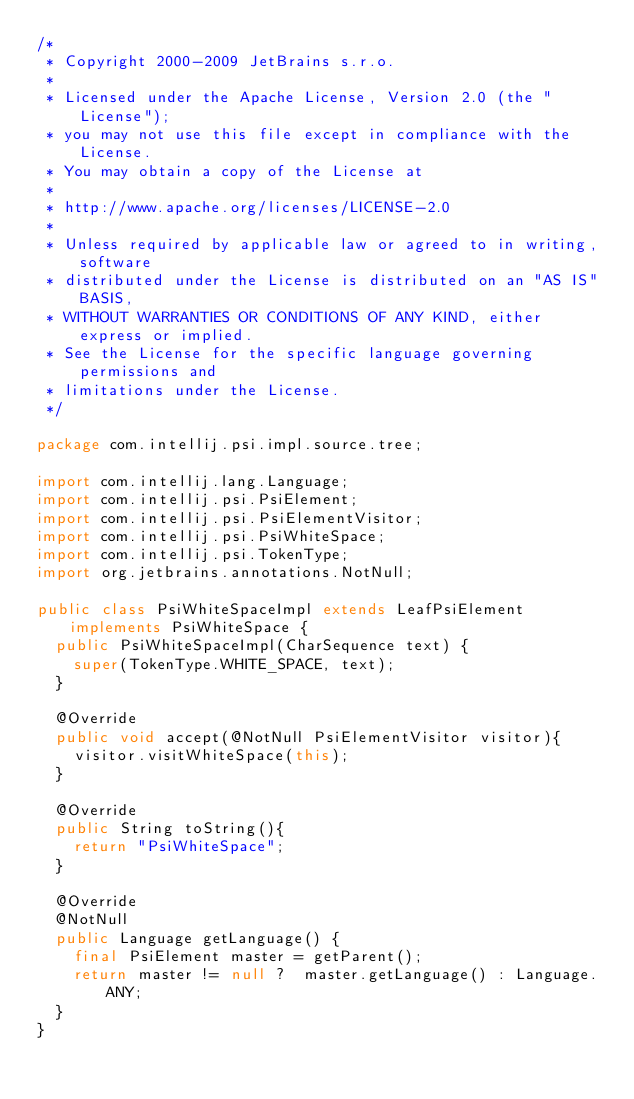<code> <loc_0><loc_0><loc_500><loc_500><_Java_>/*
 * Copyright 2000-2009 JetBrains s.r.o.
 *
 * Licensed under the Apache License, Version 2.0 (the "License");
 * you may not use this file except in compliance with the License.
 * You may obtain a copy of the License at
 *
 * http://www.apache.org/licenses/LICENSE-2.0
 *
 * Unless required by applicable law or agreed to in writing, software
 * distributed under the License is distributed on an "AS IS" BASIS,
 * WITHOUT WARRANTIES OR CONDITIONS OF ANY KIND, either express or implied.
 * See the License for the specific language governing permissions and
 * limitations under the License.
 */

package com.intellij.psi.impl.source.tree;

import com.intellij.lang.Language;
import com.intellij.psi.PsiElement;
import com.intellij.psi.PsiElementVisitor;
import com.intellij.psi.PsiWhiteSpace;
import com.intellij.psi.TokenType;
import org.jetbrains.annotations.NotNull;

public class PsiWhiteSpaceImpl extends LeafPsiElement implements PsiWhiteSpace {
  public PsiWhiteSpaceImpl(CharSequence text) {
    super(TokenType.WHITE_SPACE, text);
  }

  @Override
  public void accept(@NotNull PsiElementVisitor visitor){
    visitor.visitWhiteSpace(this);
  }

  @Override
  public String toString(){
    return "PsiWhiteSpace";
  }

  @Override
  @NotNull
  public Language getLanguage() {
    final PsiElement master = getParent();
    return master != null ?  master.getLanguage() : Language.ANY;
  }
}
</code> 